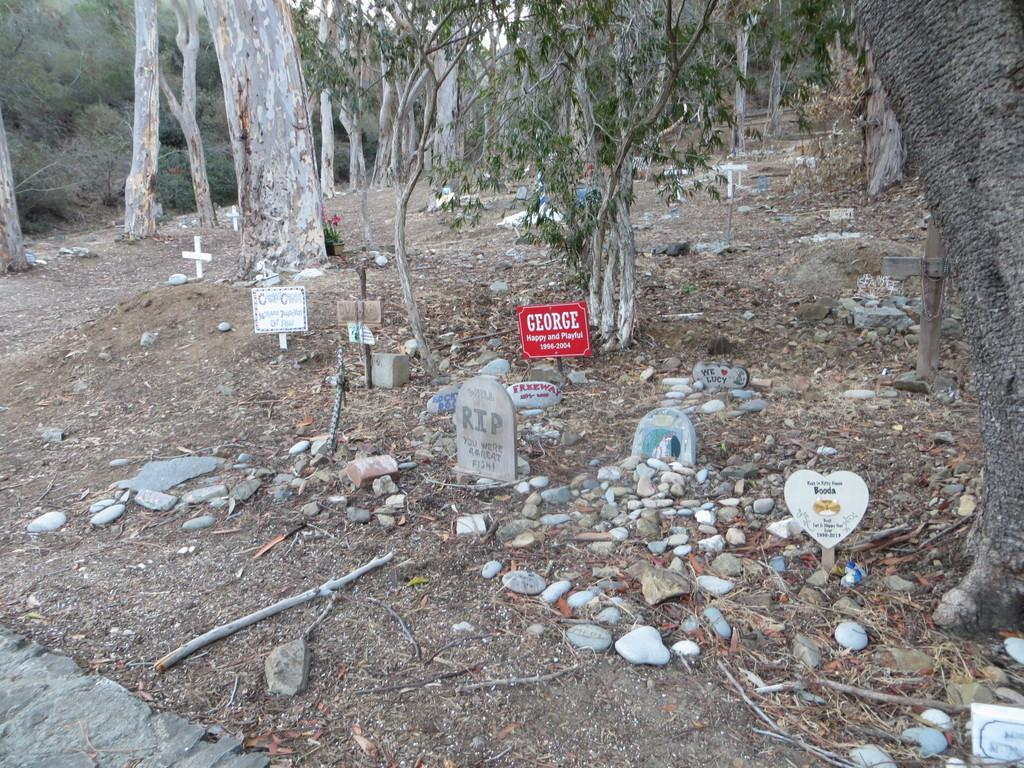What type of location is depicted in the image? There is a graveyard in the image. What can be seen in the background of the image? There are many trees in the image. What type of vessel is being used by the babies in the image? There are no babies or vessels present in the image. 